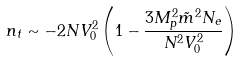<formula> <loc_0><loc_0><loc_500><loc_500>n _ { t } \sim - 2 N V _ { 0 } ^ { 2 } \left ( 1 - \frac { 3 M _ { p } ^ { 2 } \tilde { m } ^ { 2 } N _ { e } } { N ^ { 2 } V _ { 0 } ^ { 2 } } \right )</formula> 